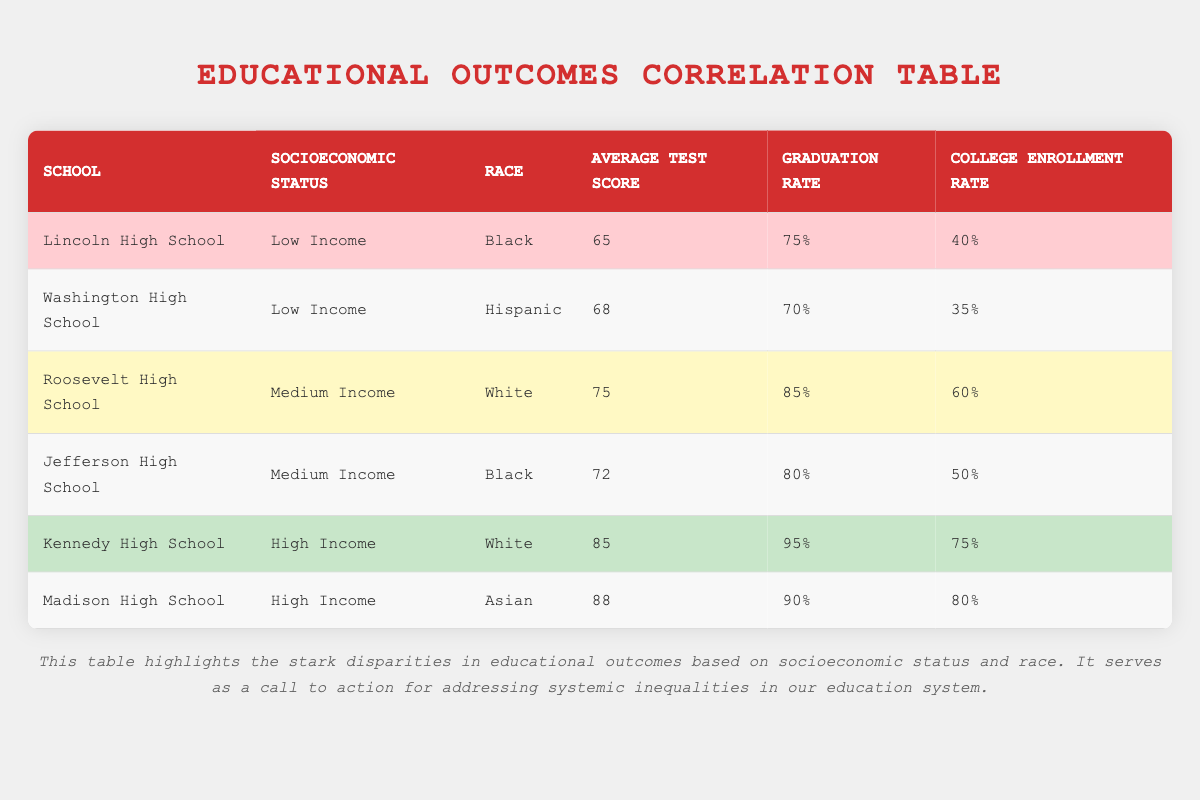What is the average test score for low-income schools? The table lists two low-income schools: Lincoln High School with a score of 65 and Washington High School with a score of 68. The average is calculated as (65 + 68) / 2 = 66.5.
Answer: 66.5 What is the graduation rate for Madison High School? The table shows that Madison High School, which has a high-income status and serves Asian students, has a graduation rate of 90%.
Answer: 90% Is the college enrollment rate for Black students at Jefferson High School higher than that for Hispanic students at Washington High School? Jefferson High School has a college enrollment rate of 50%, while Washington High School has a rate of 35%. Since 50 is greater than 35, the statement is true.
Answer: Yes What is the difference in average test scores between high-income and low-income schools? High-income schools (Kennedy: 85, Madison: 88) have an average of (85 + 88) / 2 = 86.5. Low-income schools (Lincoln: 65, Washington: 68) have an average of 66.5. The difference is 86.5 - 66.5 = 20.
Answer: 20 Do all high-income schools have a college enrollment rate above 70%? Kennedy High School has a college enrollment rate of 75%, and Madison High School has a rate of 80%. Since both rates are above 70%, the answer is true.
Answer: Yes What is the total college enrollment rate for all schools combined? The college enrollment rates are: Lincoln (40%), Washington (35%), Roosevelt (60%), Jefferson (50%), Kennedy (75%), and Madison (80%). Summing these rates: 40 + 35 + 60 + 50 + 75 + 80 = 340%. There are 6 schools, so the average is 340 / 6 = 56.67%.
Answer: 56.67% Which socioeconomic status has the highest average graduation rate? High-income schools (Kennedy: 95%, Madison: 90%) average 92.5%, while medium-income schools (Roosevelt: 85%, Jefferson: 80%) average 82.5%, and low-income schools (Lincoln: 75%, Washington: 70%) average 72.5%. Thus, high-income schools have the highest average graduation rate.
Answer: High Income How many schools have an average test score below 70? The schools with average test scores below 70 are Lincoln High School (65) and Washington High School (68). Thus, there are 2 schools with scores below 70.
Answer: 2 